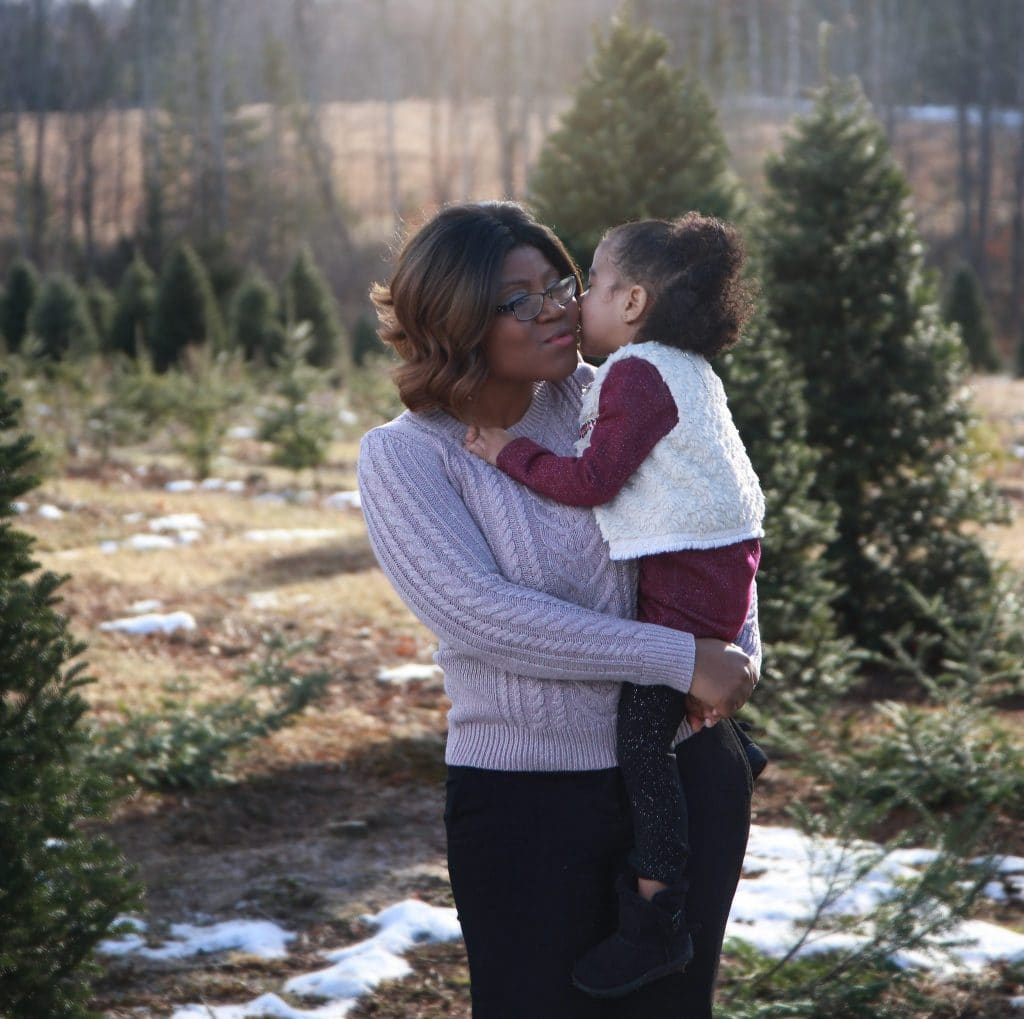What emotions does the interaction between the characters in the picture convey? The interaction portrays a warm, affectionate moment between a woman and a young child, likely indicating a close familial bond. The woman’s gentle embrace and the child reaching out to touch her face suggest feelings of love, care, and protection. 